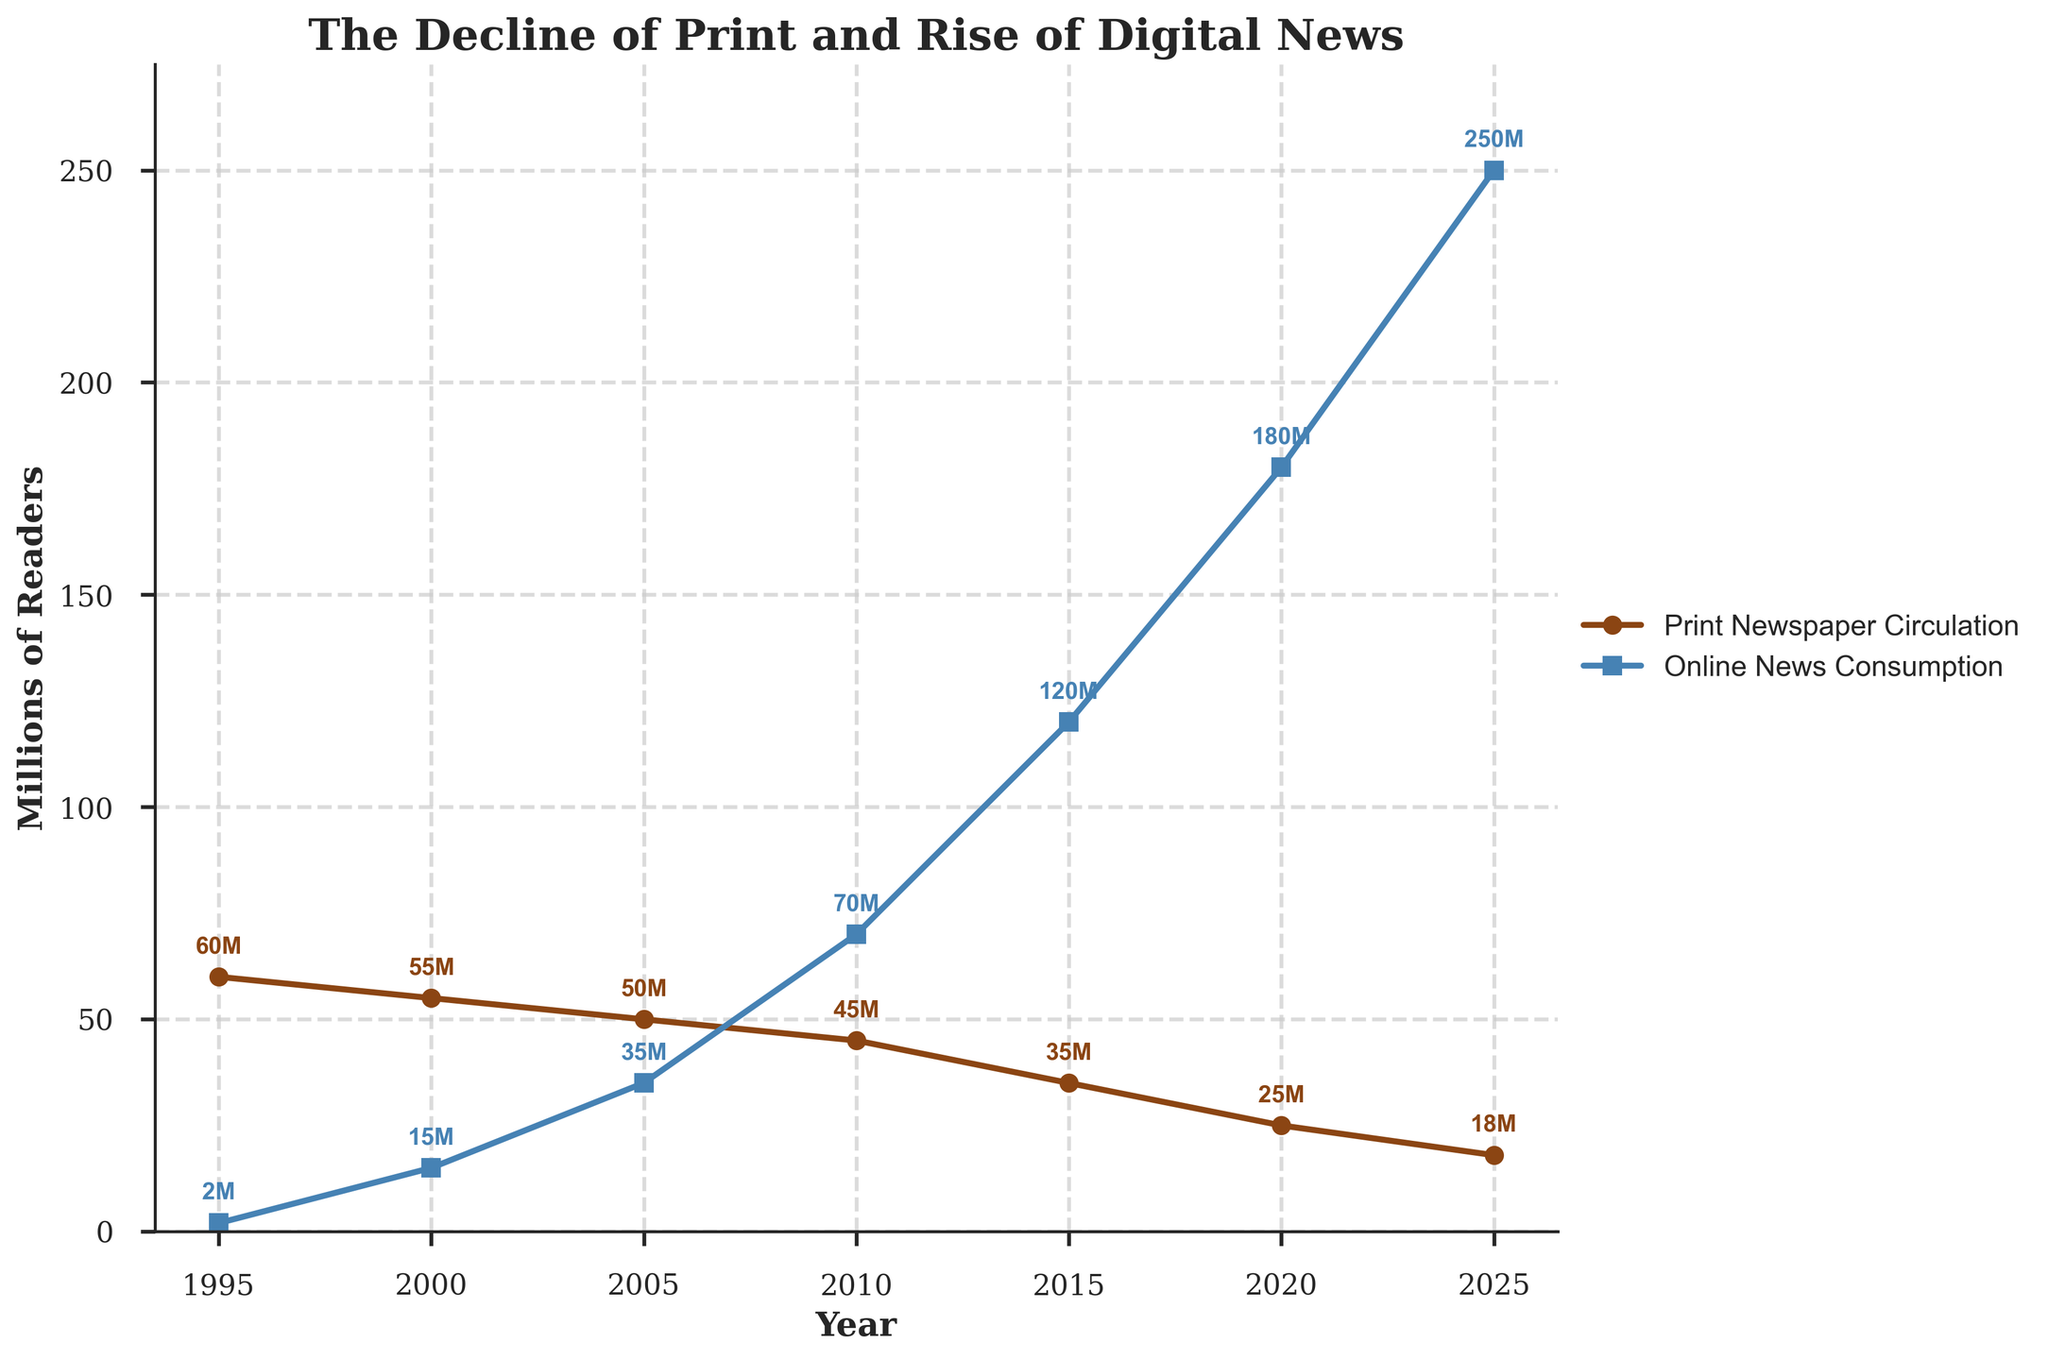What is the trend in Print Newspaper Circulation between 1995 and 2025? Observing the plot, it is clear that there is a downward trend in Print Newspaper Circulation, starting at 60 million in 1995 and declining steadily to 18 million by 2025.
Answer: Downward trend What were the values of Print Newspaper Circulation and Online News Consumption in 2020? From the figure, by looking at the year 2020, we can see that Print Newspaper Circulation is at 25 million and Online News Consumption is at 180 million.
Answer: Print: 25M, Online: 180M How much did Online News Consumption increase from 2000 to 2015? Online News Consumption was 15 million in 2000 and increased to 120 million in 2015. The increase can be calculated as 120 - 15 = 105 million.
Answer: 105 million Between which two years did Print Newspaper Circulation see the largest drop, and what was the magnitude of that drop? The largest drop in Print Newspaper Circulation happened between 2015 and 2020, with a decline from 35 million to 25 million, a difference of 10 million.
Answer: 2015 to 2020, 10 million What is the difference in millions of readers between the highest and lowest values of Online News Consumption? The highest value of Online News Consumption is 250 million in 2025, and the lowest is 2 million in 1995. The difference is 250 - 2 = 248 million.
Answer: 248 million In which year did Online News Consumption surpass Print Newspaper Circulation, and by how much? In the year 2010, Online News Consumption surpassed Print Newspaper Circulation. Online Consumption was 70 million while Print Circulation was 45 million. The difference is 70 - 45 = 25 million.
Answer: 2010, 25 million What is the average value of Print Newspaper Circulation over the plotted years? The values of Print Newspaper Circulation are 60, 55, 50, 45, 35, 25, and 18 million. The sum is 288 million, and there are 7 values, so the average is 288 / 7 ≈ 41.14 million.
Answer: 41.14 million Comparing the year 2005 to 2025, how many more million online readers are there compared to print readers? In 2005, Print Newspaper Circulation was 50 million and Online News Consumption was 35 million. By 2025, Print Newspaper Circulation dropped to 18 million while Online News Consumption rose to 250 million. The difference in a comparison is 250 - 18 = 232 million.
Answer: 232 million 